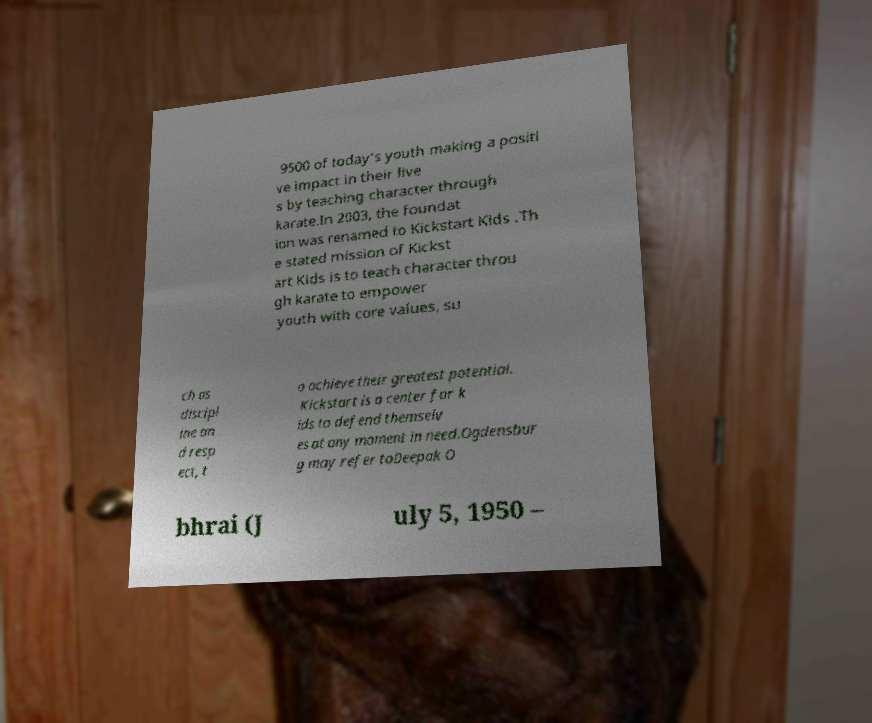Could you extract and type out the text from this image? 9500 of today's youth making a positi ve impact in their live s by teaching character through karate.In 2003, the foundat ion was renamed to Kickstart Kids .Th e stated mission of Kickst art Kids is to teach character throu gh karate to empower youth with core values, su ch as discipl ine an d resp ect, t o achieve their greatest potential. Kickstart is a center for k ids to defend themselv es at any moment in need.Ogdensbur g may refer toDeepak O bhrai (J uly 5, 1950 – 